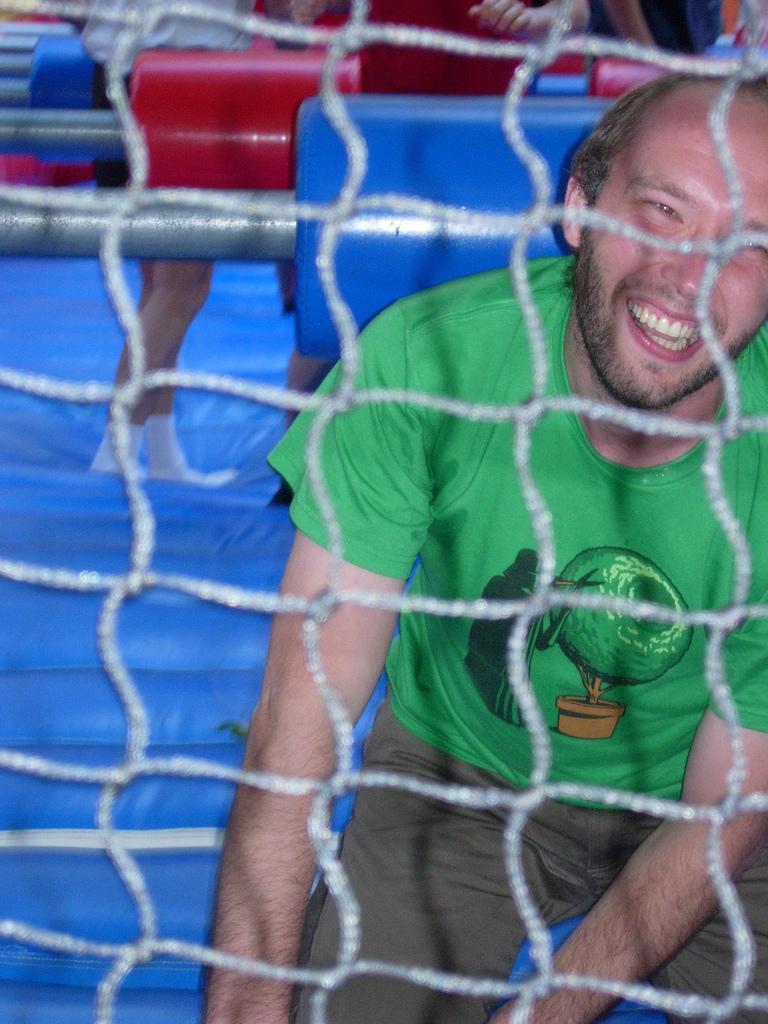Can you describe this image briefly? In the center of the image there is a fence. Through the fence, we can see one person is sitting and he is smiling and we can see he is in a green t shirt. In the background, we can see red color objects, blue color objects and a few other objects. On one of the blue color objects, we can see two persons are standing. 